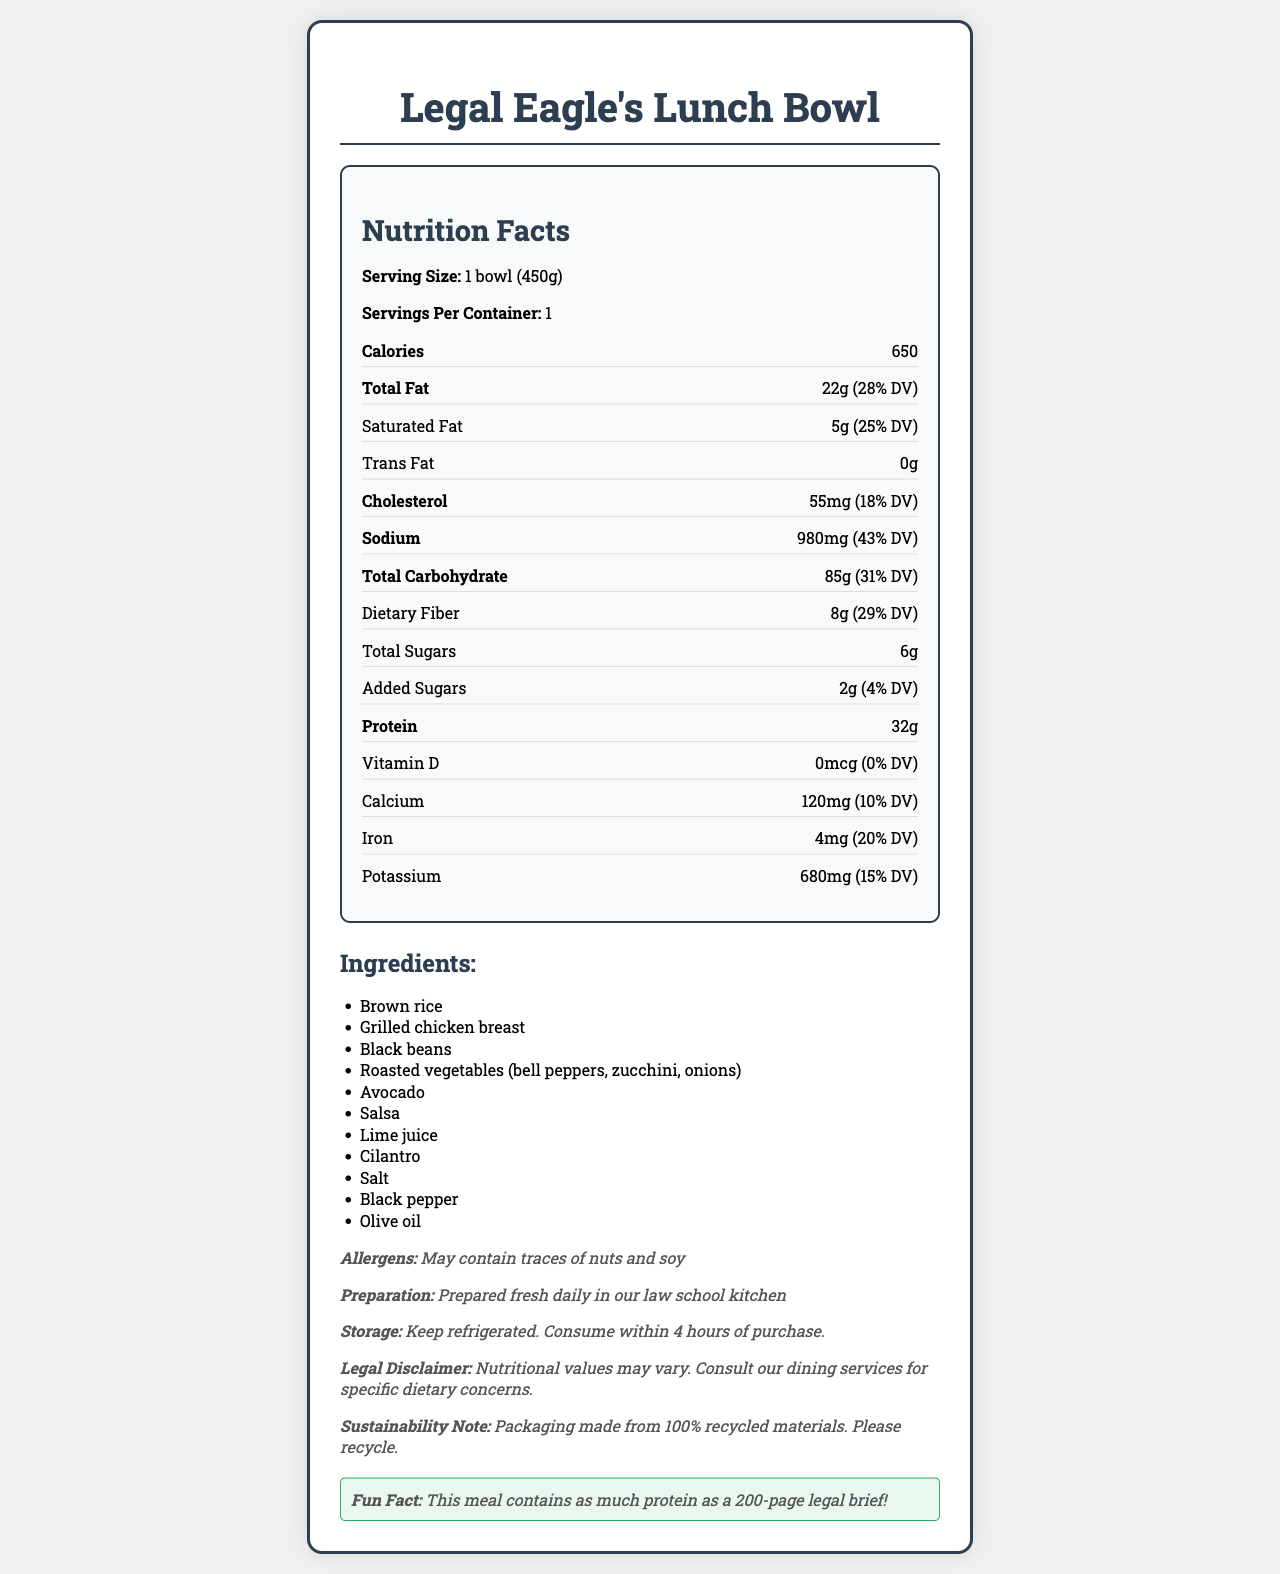What is the serving size of Legal Eagle's Lunch Bowl? The serving size is displayed at the top of the Nutrition Facts section, labeled as "Serving Size: 1 bowl (450g)".
Answer: 1 bowl (450g) How many calories are in one serving of Legal Eagle's Lunch Bowl? The document specifies that there are 650 calories in one serving of the meal.
Answer: 650 What are the total fat and its daily value percentage in a serving? The total fat content is listed as 22g, and the daily value (DV) percentage is 28%.
Answer: 22g (28% DV) How much protein does the meal provide? The document mentions that the meal contains 32g of protein per serving.
Answer: 32g What are the main ingredients in Legal Eagle's Lunch Bowl? The ingredients are listed under the "Ingredients" section in the document.
Answer: Brown rice, Grilled chicken breast, Black beans, Roasted vegetables, Avocado, Salsa, Lime juice, Cilantro, Salt, Black pepper, Olive oil What is the daily value percentage of sodium in this meal? The Nutrition Facts section lists sodium as 980mg, which is 43% of the daily value.
Answer: 43% Which of the following is NOT an ingredient in the meal? A. Black beans B. Avocado C. Quinoa D. Salsa Quinoa is not listed among the ingredients in the meal.
Answer: C What is the amount of dietary fiber and its daily value percentage? The dietary fiber content is 8g, and the daily value percentage is 29%.
Answer: 8g (29% DV) True or False: This meal contains added sugars. The document states that the meal contains 2g of added sugars (4% DV).
Answer: True What is the calcium content and its daily value percentage? Calcium content is 120mg, which is 10% of the daily value.
Answer: 120mg (10% DV) Summarize the main information provided about Legal Eagle's Lunch Bowl. The document not only provides nutritional information but also details about ingredients, allergens, preparation and storage, with extra notes on sustainability and a fun fact about protein content.
Answer: Legal Eagle's Lunch Bowl is a cafeteria meal with 650 calories per serving (450g). It contains 22g of total fat (28% DV), 5g of saturated fat (25% DV), and provides 32g of protein. The meal includes ingredients like brown rice, grilled chicken breast, black beans, roasted vegetables, and avocado. The document also highlights possible allergens, preparation, and storage instructions, a legal disclaimer, and a sustainability note. Is there any information on the vitamin D content in this meal? If yes, what is it? The document lists vitamin D content as 0mcg, which is 0% of the daily value.
Answer: 0mcg (0% DV) How much cholesterol does the meal have, and what percentage of the daily value does it represent? The cholesterol content is 55mg, and it is 18% of the daily value.
Answer: 55mg (18% DV) Which of the following nutrients has no daily value percentage listed? A. Total Sugars B. Saturated Fat C. Iron D. Vitamin D The document provides daily value percentages for all options except 'Total Sugars'.
Answer: A What is one fun fact mentioned about this meal? The Fun Fact section of the document mentions this comparison to highlight the protein content of the meal.
Answer: This meal contains as much protein as a 200-page legal brief! What is the recommended storage instruction for this meal? The storage instructions are clearly listed under the "Storage" section.
Answer: Keep refrigerated. Consume within 4 hours of purchase. What are the allergen warnings associated with this meal? The allergen information is provided under the "Allergens" section of the document.
Answer: May contain traces of nuts and soy Can you determine the cooking method used for preparing the grilled chicken breast? The document mentions "Grilled chicken breast" but does not provide specific cooking methods or details.
Answer: Not enough information 